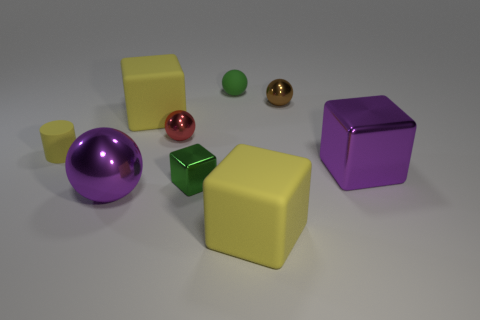Subtract all small green rubber spheres. How many spheres are left? 3 Add 1 brown rubber cubes. How many objects exist? 10 Subtract all green blocks. How many blocks are left? 3 Subtract 1 cylinders. How many cylinders are left? 0 Subtract all cylinders. How many objects are left? 8 Subtract all tiny metallic objects. Subtract all large metallic objects. How many objects are left? 4 Add 6 small green metallic cubes. How many small green metallic cubes are left? 7 Add 4 purple cylinders. How many purple cylinders exist? 4 Subtract 0 blue cubes. How many objects are left? 9 Subtract all green balls. Subtract all gray blocks. How many balls are left? 3 